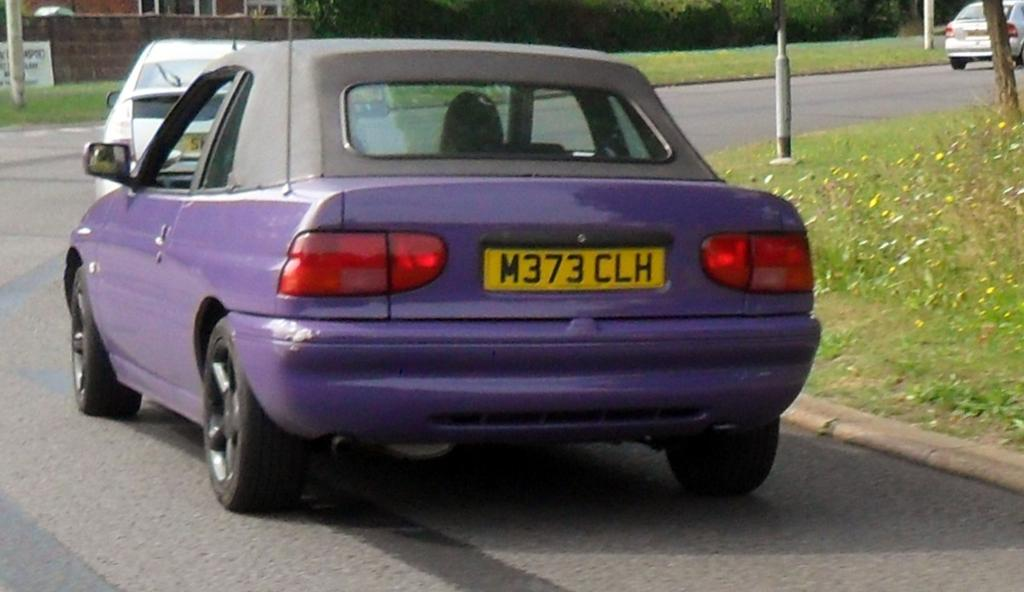What type of vehicles can be seen on the road in the image? There are cars on the road in the image. What is visible in the background of the image? There is a building and trees in the background of the image. What type of vegetation is visible in the image? There is grass visible in the image. Can you see a rat running across the grass in the image? There is no rat present in the image; it only features cars on the road, a building, trees, and grass. 